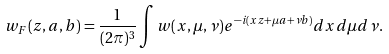Convert formula to latex. <formula><loc_0><loc_0><loc_500><loc_500>w _ { F } ( z , a , b ) = \frac { 1 } { ( 2 \pi ) ^ { 3 } } \int w ( x , \mu , \nu ) e ^ { - i ( x z + \mu a + \nu b ) } d x d \mu d \nu .</formula> 